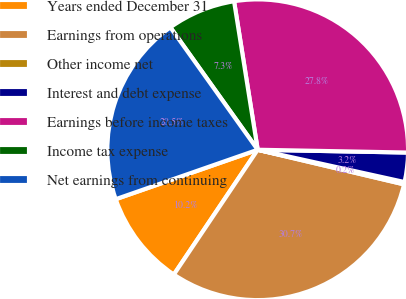Convert chart. <chart><loc_0><loc_0><loc_500><loc_500><pie_chart><fcel>Years ended December 31<fcel>Earnings from operations<fcel>Other income net<fcel>Interest and debt expense<fcel>Earnings before income taxes<fcel>Income tax expense<fcel>Net earnings from continuing<nl><fcel>10.25%<fcel>30.72%<fcel>0.25%<fcel>3.15%<fcel>27.81%<fcel>7.35%<fcel>20.47%<nl></chart> 